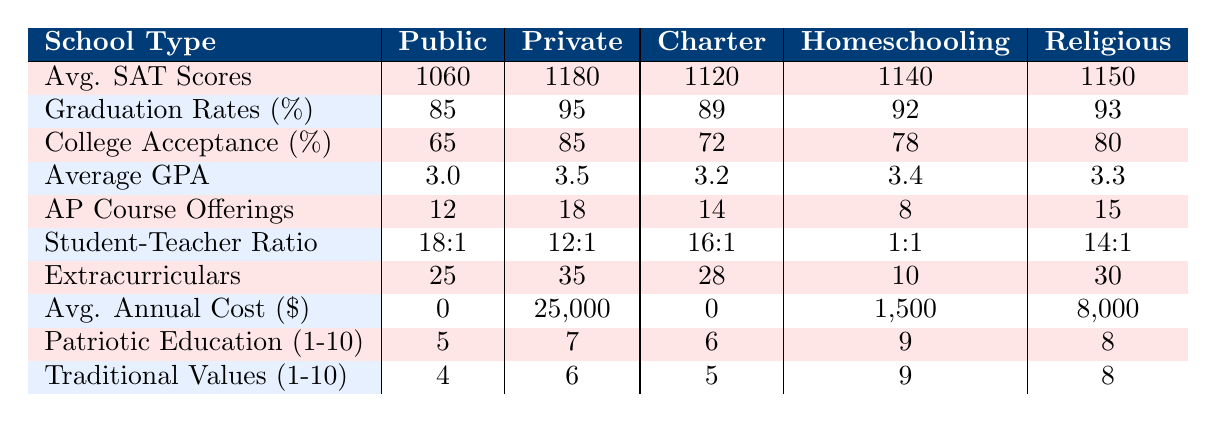What is the average SAT score for Private Schools? The table shows that the average SAT score for Private Schools is 1180 directly under the "Avg. SAT Scores" row.
Answer: 1180 Which school type has the highest graduation rate? Looking at the "Graduation Rates (%)" row, Private Schools have the highest graduation rate at 95%.
Answer: Private Schools What is the difference in average GPA between Public Schools and Private Schools? The average GPA for Public Schools is 3.0 and for Private Schools is 3.5. The difference is 3.5 - 3.0 = 0.5.
Answer: 0.5 What is the average score in the Patriotic Education for all school types? The scores for Patriotic Education are 5, 7, 6, 9, and 8. The average is (5 + 7 + 6 + 9 + 8) / 5 = 35 / 5 = 7.
Answer: 7 Is it true that Homeschooling has the lowest annual cost? The average annual cost for Homeschooling is $1500, which is less than the costs of all other school types mentioned in the table. Thus, it is true.
Answer: Yes How many more AP course offerings do Private Schools have compared to Homeschooling? Private Schools offer 18 AP courses while Homeschooling offers 8. The difference is 18 - 8 = 10.
Answer: 10 Which school type has the best student-teacher ratio? The table shows that Homeschooling has the best student-teacher ratio of 1:1, which is better than any other school type listed.
Answer: Homeschooling What is the total number of Extracurricular Activities offered by Public and Charter Schools combined? Public Schools offer 25 extracurricular activities, and Charter Schools offer 28. Adding them together gives 25 + 28 = 53 activities.
Answer: 53 What is the Traditional Values score of Charter Schools compared to Private Schools? Charter Schools have a score of 5, while Private Schools have a score of 6. Since 5 is less than 6, Charter Schools have a lower score.
Answer: Lower How do the average SAT scores of Religious Schools compare to Charter Schools? The average SAT score for Religious Schools is 1150, which is higher than the 1120 score for Charter Schools. Thus, Religious Schools have a higher SAT score.
Answer: Higher 